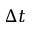<formula> <loc_0><loc_0><loc_500><loc_500>\Delta t</formula> 